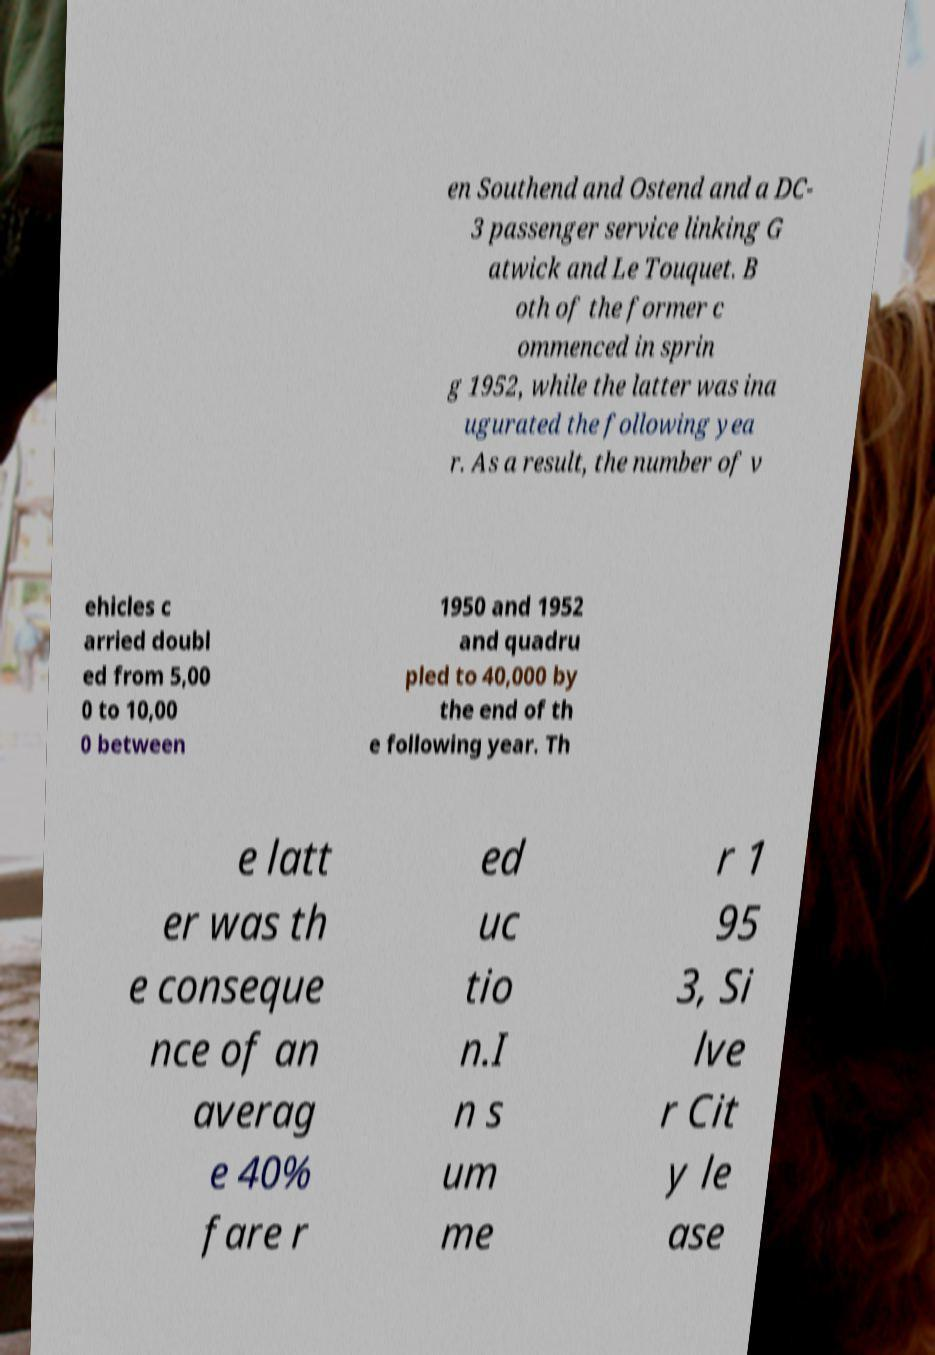For documentation purposes, I need the text within this image transcribed. Could you provide that? en Southend and Ostend and a DC- 3 passenger service linking G atwick and Le Touquet. B oth of the former c ommenced in sprin g 1952, while the latter was ina ugurated the following yea r. As a result, the number of v ehicles c arried doubl ed from 5,00 0 to 10,00 0 between 1950 and 1952 and quadru pled to 40,000 by the end of th e following year. Th e latt er was th e conseque nce of an averag e 40% fare r ed uc tio n.I n s um me r 1 95 3, Si lve r Cit y le ase 